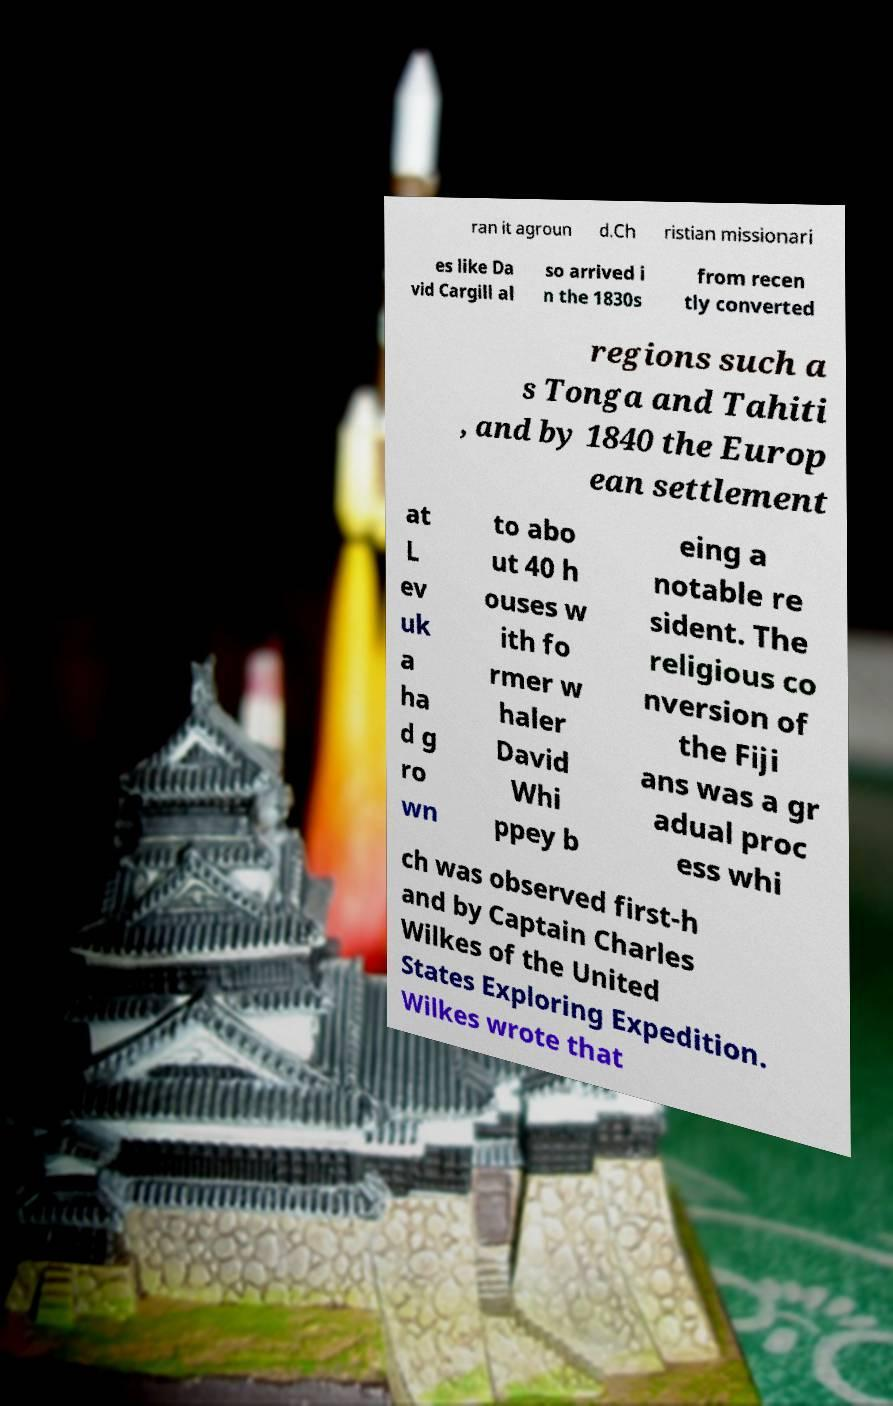Can you read and provide the text displayed in the image?This photo seems to have some interesting text. Can you extract and type it out for me? ran it agroun d.Ch ristian missionari es like Da vid Cargill al so arrived i n the 1830s from recen tly converted regions such a s Tonga and Tahiti , and by 1840 the Europ ean settlement at L ev uk a ha d g ro wn to abo ut 40 h ouses w ith fo rmer w haler David Whi ppey b eing a notable re sident. The religious co nversion of the Fiji ans was a gr adual proc ess whi ch was observed first-h and by Captain Charles Wilkes of the United States Exploring Expedition. Wilkes wrote that 